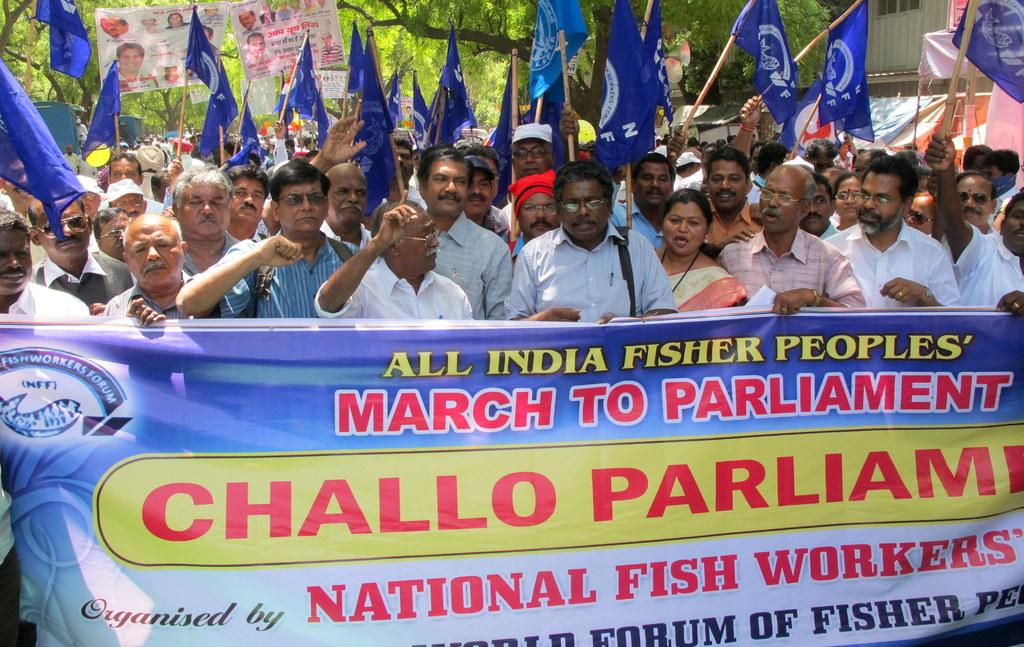What are the people in the image doing? The people in the image are holding flags. What else can be seen in the image besides the people holding flags? There is a banner with writing in the image, and some people are holding placards. Where is the banner located in relation to the people holding flags? The banner is in front of the people holding flags. What is visible in the background of the image? There are trees in the background of the image. What type of pets are visible in the image? There are no pets visible in the image. Who is the partner of the person holding the flag in the image? There is no information about a partner in the image. 